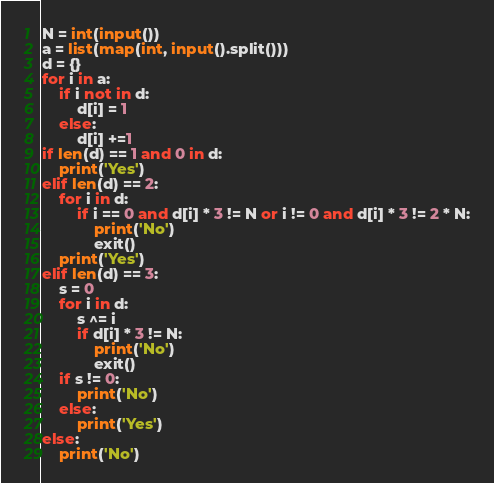<code> <loc_0><loc_0><loc_500><loc_500><_Python_>N = int(input())
a = list(map(int, input().split()))
d = {}
for i in a:
    if i not in d:
        d[i] = 1
    else:
        d[i] +=1
if len(d) == 1 and 0 in d:
    print('Yes')
elif len(d) == 2:
    for i in d:
        if i == 0 and d[i] * 3 != N or i != 0 and d[i] * 3 != 2 * N:
            print('No')
            exit()
    print('Yes')
elif len(d) == 3:
    s = 0
    for i in d:
        s ^= i
        if d[i] * 3 != N:
            print('No')
            exit()
    if s != 0:
        print('No')
    else:
        print('Yes')
else:
    print('No')
</code> 